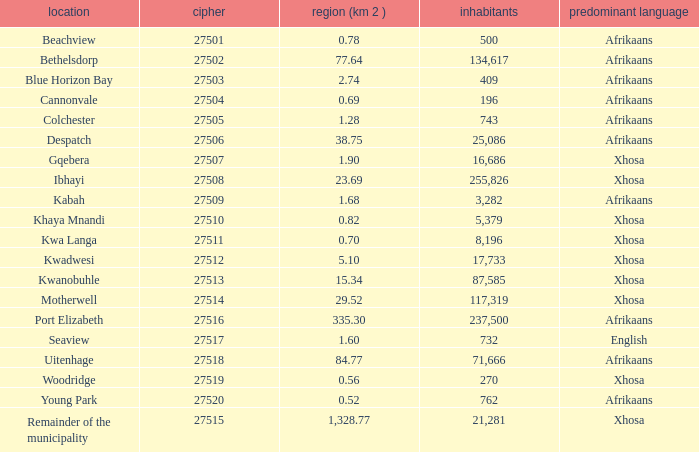What is the lowest code number for the remainder of the municipality that has an area bigger than 15.34 squared kilometers, a population greater than 762 and a language of xhosa spoken? 27515.0. 